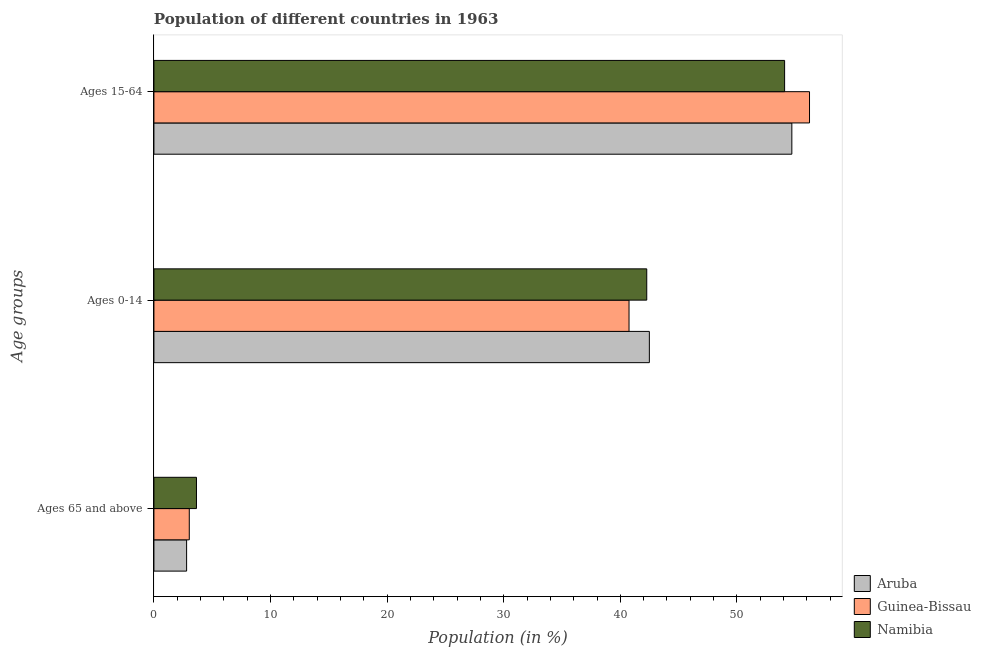Are the number of bars per tick equal to the number of legend labels?
Give a very brief answer. Yes. Are the number of bars on each tick of the Y-axis equal?
Offer a very short reply. Yes. How many bars are there on the 1st tick from the bottom?
Offer a very short reply. 3. What is the label of the 2nd group of bars from the top?
Provide a short and direct response. Ages 0-14. What is the percentage of population within the age-group 0-14 in Aruba?
Your answer should be very brief. 42.49. Across all countries, what is the maximum percentage of population within the age-group 15-64?
Provide a succinct answer. 56.22. Across all countries, what is the minimum percentage of population within the age-group 0-14?
Your answer should be very brief. 40.75. In which country was the percentage of population within the age-group 15-64 maximum?
Keep it short and to the point. Guinea-Bissau. In which country was the percentage of population within the age-group of 65 and above minimum?
Provide a succinct answer. Aruba. What is the total percentage of population within the age-group of 65 and above in the graph?
Offer a very short reply. 9.48. What is the difference between the percentage of population within the age-group 15-64 in Aruba and that in Guinea-Bissau?
Ensure brevity in your answer.  -1.51. What is the difference between the percentage of population within the age-group 0-14 in Guinea-Bissau and the percentage of population within the age-group of 65 and above in Aruba?
Your response must be concise. 37.94. What is the average percentage of population within the age-group 15-64 per country?
Make the answer very short. 55.01. What is the difference between the percentage of population within the age-group of 65 and above and percentage of population within the age-group 0-14 in Namibia?
Your answer should be compact. -38.62. In how many countries, is the percentage of population within the age-group 15-64 greater than 14 %?
Ensure brevity in your answer.  3. What is the ratio of the percentage of population within the age-group of 65 and above in Aruba to that in Guinea-Bissau?
Offer a very short reply. 0.92. Is the percentage of population within the age-group 15-64 in Guinea-Bissau less than that in Aruba?
Your answer should be compact. No. Is the difference between the percentage of population within the age-group 0-14 in Guinea-Bissau and Namibia greater than the difference between the percentage of population within the age-group of 65 and above in Guinea-Bissau and Namibia?
Your answer should be compact. No. What is the difference between the highest and the second highest percentage of population within the age-group 15-64?
Offer a very short reply. 1.51. What is the difference between the highest and the lowest percentage of population within the age-group 15-64?
Ensure brevity in your answer.  2.14. In how many countries, is the percentage of population within the age-group 15-64 greater than the average percentage of population within the age-group 15-64 taken over all countries?
Your answer should be very brief. 1. Is the sum of the percentage of population within the age-group 0-14 in Namibia and Aruba greater than the maximum percentage of population within the age-group 15-64 across all countries?
Keep it short and to the point. Yes. What does the 1st bar from the top in Ages 65 and above represents?
Your answer should be very brief. Namibia. What does the 1st bar from the bottom in Ages 15-64 represents?
Offer a terse response. Aruba. Is it the case that in every country, the sum of the percentage of population within the age-group of 65 and above and percentage of population within the age-group 0-14 is greater than the percentage of population within the age-group 15-64?
Your response must be concise. No. How many bars are there?
Keep it short and to the point. 9. What is the difference between two consecutive major ticks on the X-axis?
Keep it short and to the point. 10. How many legend labels are there?
Ensure brevity in your answer.  3. How are the legend labels stacked?
Ensure brevity in your answer.  Vertical. What is the title of the graph?
Keep it short and to the point. Population of different countries in 1963. Does "Virgin Islands" appear as one of the legend labels in the graph?
Ensure brevity in your answer.  No. What is the label or title of the X-axis?
Your answer should be compact. Population (in %). What is the label or title of the Y-axis?
Make the answer very short. Age groups. What is the Population (in %) in Aruba in Ages 65 and above?
Offer a terse response. 2.8. What is the Population (in %) of Guinea-Bissau in Ages 65 and above?
Offer a terse response. 3.03. What is the Population (in %) of Namibia in Ages 65 and above?
Give a very brief answer. 3.65. What is the Population (in %) in Aruba in Ages 0-14?
Your response must be concise. 42.49. What is the Population (in %) in Guinea-Bissau in Ages 0-14?
Your answer should be very brief. 40.75. What is the Population (in %) of Namibia in Ages 0-14?
Provide a short and direct response. 42.26. What is the Population (in %) in Aruba in Ages 15-64?
Provide a succinct answer. 54.71. What is the Population (in %) of Guinea-Bissau in Ages 15-64?
Your answer should be compact. 56.22. What is the Population (in %) of Namibia in Ages 15-64?
Your response must be concise. 54.09. Across all Age groups, what is the maximum Population (in %) of Aruba?
Your answer should be compact. 54.71. Across all Age groups, what is the maximum Population (in %) of Guinea-Bissau?
Offer a very short reply. 56.22. Across all Age groups, what is the maximum Population (in %) of Namibia?
Provide a succinct answer. 54.09. Across all Age groups, what is the minimum Population (in %) of Aruba?
Keep it short and to the point. 2.8. Across all Age groups, what is the minimum Population (in %) of Guinea-Bissau?
Your response must be concise. 3.03. Across all Age groups, what is the minimum Population (in %) in Namibia?
Your response must be concise. 3.65. What is the difference between the Population (in %) of Aruba in Ages 65 and above and that in Ages 0-14?
Offer a terse response. -39.69. What is the difference between the Population (in %) in Guinea-Bissau in Ages 65 and above and that in Ages 0-14?
Offer a very short reply. -37.71. What is the difference between the Population (in %) of Namibia in Ages 65 and above and that in Ages 0-14?
Keep it short and to the point. -38.62. What is the difference between the Population (in %) of Aruba in Ages 65 and above and that in Ages 15-64?
Provide a short and direct response. -51.91. What is the difference between the Population (in %) of Guinea-Bissau in Ages 65 and above and that in Ages 15-64?
Give a very brief answer. -53.19. What is the difference between the Population (in %) in Namibia in Ages 65 and above and that in Ages 15-64?
Offer a terse response. -50.44. What is the difference between the Population (in %) in Aruba in Ages 0-14 and that in Ages 15-64?
Ensure brevity in your answer.  -12.22. What is the difference between the Population (in %) in Guinea-Bissau in Ages 0-14 and that in Ages 15-64?
Give a very brief answer. -15.48. What is the difference between the Population (in %) in Namibia in Ages 0-14 and that in Ages 15-64?
Keep it short and to the point. -11.82. What is the difference between the Population (in %) of Aruba in Ages 65 and above and the Population (in %) of Guinea-Bissau in Ages 0-14?
Your answer should be compact. -37.94. What is the difference between the Population (in %) of Aruba in Ages 65 and above and the Population (in %) of Namibia in Ages 0-14?
Provide a short and direct response. -39.46. What is the difference between the Population (in %) in Guinea-Bissau in Ages 65 and above and the Population (in %) in Namibia in Ages 0-14?
Make the answer very short. -39.23. What is the difference between the Population (in %) in Aruba in Ages 65 and above and the Population (in %) in Guinea-Bissau in Ages 15-64?
Offer a very short reply. -53.42. What is the difference between the Population (in %) in Aruba in Ages 65 and above and the Population (in %) in Namibia in Ages 15-64?
Make the answer very short. -51.28. What is the difference between the Population (in %) in Guinea-Bissau in Ages 65 and above and the Population (in %) in Namibia in Ages 15-64?
Provide a succinct answer. -51.06. What is the difference between the Population (in %) in Aruba in Ages 0-14 and the Population (in %) in Guinea-Bissau in Ages 15-64?
Your response must be concise. -13.73. What is the difference between the Population (in %) in Aruba in Ages 0-14 and the Population (in %) in Namibia in Ages 15-64?
Make the answer very short. -11.6. What is the difference between the Population (in %) in Guinea-Bissau in Ages 0-14 and the Population (in %) in Namibia in Ages 15-64?
Keep it short and to the point. -13.34. What is the average Population (in %) in Aruba per Age groups?
Your answer should be compact. 33.33. What is the average Population (in %) in Guinea-Bissau per Age groups?
Your answer should be compact. 33.33. What is the average Population (in %) in Namibia per Age groups?
Your answer should be very brief. 33.33. What is the difference between the Population (in %) in Aruba and Population (in %) in Guinea-Bissau in Ages 65 and above?
Keep it short and to the point. -0.23. What is the difference between the Population (in %) of Aruba and Population (in %) of Namibia in Ages 65 and above?
Keep it short and to the point. -0.85. What is the difference between the Population (in %) in Guinea-Bissau and Population (in %) in Namibia in Ages 65 and above?
Ensure brevity in your answer.  -0.62. What is the difference between the Population (in %) of Aruba and Population (in %) of Guinea-Bissau in Ages 0-14?
Provide a succinct answer. 1.74. What is the difference between the Population (in %) in Aruba and Population (in %) in Namibia in Ages 0-14?
Provide a short and direct response. 0.22. What is the difference between the Population (in %) of Guinea-Bissau and Population (in %) of Namibia in Ages 0-14?
Provide a succinct answer. -1.52. What is the difference between the Population (in %) in Aruba and Population (in %) in Guinea-Bissau in Ages 15-64?
Offer a very short reply. -1.51. What is the difference between the Population (in %) of Aruba and Population (in %) of Namibia in Ages 15-64?
Make the answer very short. 0.62. What is the difference between the Population (in %) of Guinea-Bissau and Population (in %) of Namibia in Ages 15-64?
Offer a terse response. 2.14. What is the ratio of the Population (in %) of Aruba in Ages 65 and above to that in Ages 0-14?
Make the answer very short. 0.07. What is the ratio of the Population (in %) in Guinea-Bissau in Ages 65 and above to that in Ages 0-14?
Offer a terse response. 0.07. What is the ratio of the Population (in %) of Namibia in Ages 65 and above to that in Ages 0-14?
Keep it short and to the point. 0.09. What is the ratio of the Population (in %) in Aruba in Ages 65 and above to that in Ages 15-64?
Provide a short and direct response. 0.05. What is the ratio of the Population (in %) in Guinea-Bissau in Ages 65 and above to that in Ages 15-64?
Your answer should be very brief. 0.05. What is the ratio of the Population (in %) in Namibia in Ages 65 and above to that in Ages 15-64?
Give a very brief answer. 0.07. What is the ratio of the Population (in %) of Aruba in Ages 0-14 to that in Ages 15-64?
Provide a short and direct response. 0.78. What is the ratio of the Population (in %) in Guinea-Bissau in Ages 0-14 to that in Ages 15-64?
Your answer should be very brief. 0.72. What is the ratio of the Population (in %) in Namibia in Ages 0-14 to that in Ages 15-64?
Give a very brief answer. 0.78. What is the difference between the highest and the second highest Population (in %) of Aruba?
Keep it short and to the point. 12.22. What is the difference between the highest and the second highest Population (in %) in Guinea-Bissau?
Your answer should be very brief. 15.48. What is the difference between the highest and the second highest Population (in %) of Namibia?
Make the answer very short. 11.82. What is the difference between the highest and the lowest Population (in %) in Aruba?
Make the answer very short. 51.91. What is the difference between the highest and the lowest Population (in %) in Guinea-Bissau?
Give a very brief answer. 53.19. What is the difference between the highest and the lowest Population (in %) in Namibia?
Ensure brevity in your answer.  50.44. 